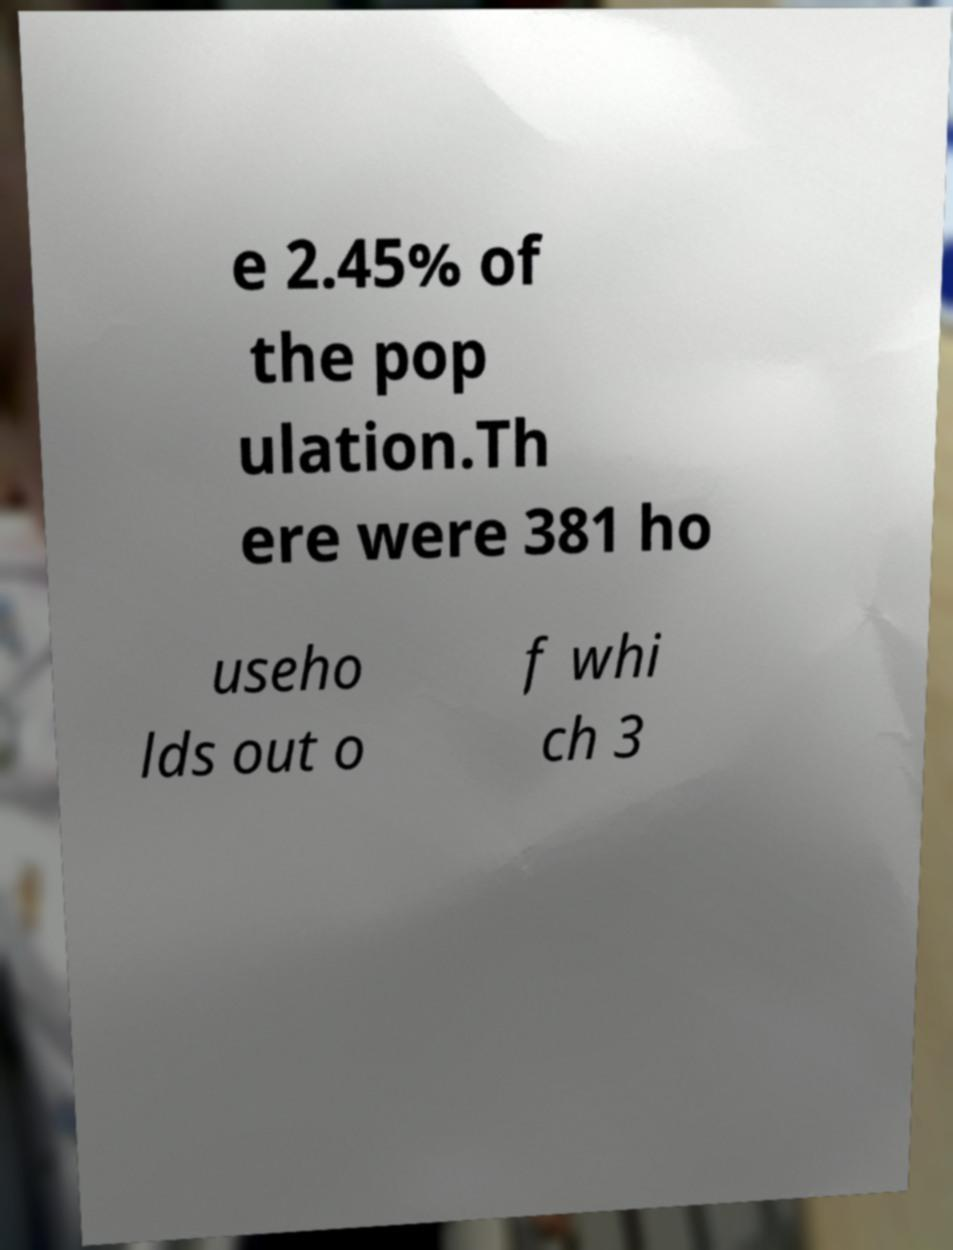For documentation purposes, I need the text within this image transcribed. Could you provide that? e 2.45% of the pop ulation.Th ere were 381 ho useho lds out o f whi ch 3 